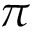<formula> <loc_0><loc_0><loc_500><loc_500>\pi</formula> 